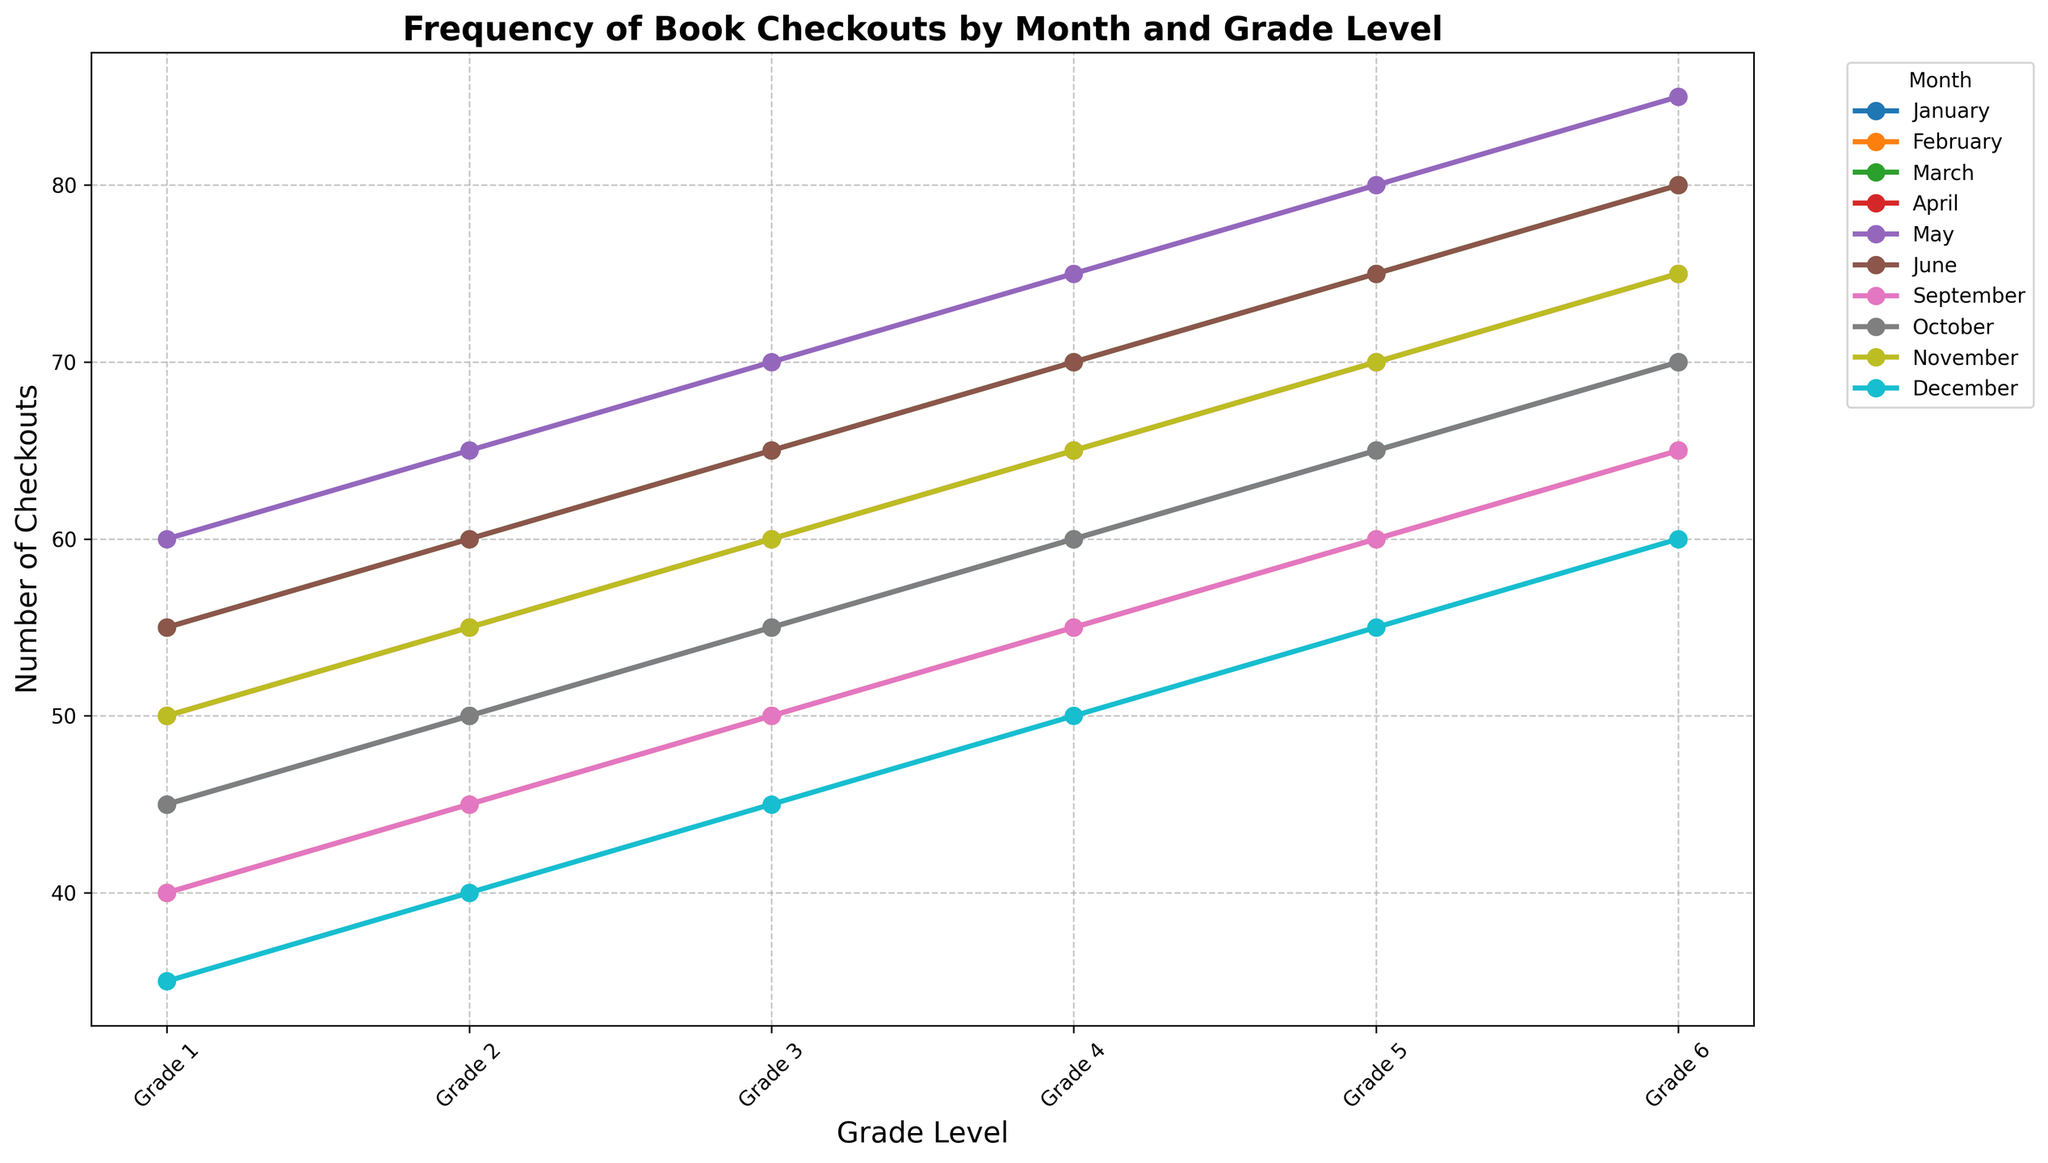Which grade level has the highest number of checkouts in May? Check the plot for the line representing May and identify the point with the highest number of checkouts.
Answer: Grade 6 Compare the number of checkouts in June for Grade 1 and Grade 6. Look at the data points for June corresponding to Grade 1 and Grade 6 and note their values. Grade 1 has 55 checkouts, and Grade 6 has 80 checkouts.
Answer: Grade 6 has more checkouts in June Which month has the lowest number of checkouts for Grade 3? Identify the lowest data point on the Grade 3 line across all months. December has the lowest with 45 checkouts.
Answer: December What is the average number of checkouts in January across all grade levels? Sum the values for all grades in January and divide by the number of grades: (45 + 50 + 55 + 60 + 65 + 70) / 6 = 345 / 6 = 57.5
Answer: 57.5 In which month do Grade 5 checkouts peak? Find the maximum point on the Grade 5 line and observe its corresponding month. May has the highest checkouts with 80.
Answer: May Identify the trend in the number of checkouts for Grade 2 from January to March. Analyze the data points for Grade 2 from January to March to observe any changes. Checkouts increase from 50 in January to 60 in March.
Answer: Increasing trend How many more checkouts were there in February compared to September for Grade 4? Subtract the number of checkouts in September for Grade 4 from the checkouts in February for Grade 4: 55 - 55 = 0.
Answer: 0 What month has the most consistent number of checkouts across all grade levels? Observe the lines representing each month and identify the month with the least variation in values across grades. Both January and June have relatively stable lines.
Answer: January or June Calculate the difference in checkouts between the highest and lowest values for Grade 6. Identify the highest and lowest points for Grade 6: the highest is 85 (May), and the lowest is 60 (December). The difference is 85 - 60 = 25.
Answer: 25 Which grade has the highest increase in checkouts from April to May? Find the difference in the number of checkouts from April to May for each grade and identify the largest increase. Grade 1 increases from 50 to 60, Grade 2 from 55 to 65, Grade 3 from 60 to 70, Grade 4 from 65 to 75, Grade 5 from 70 to 80, and Grade 6 from 75 to 85.
Answer: Grade 6 